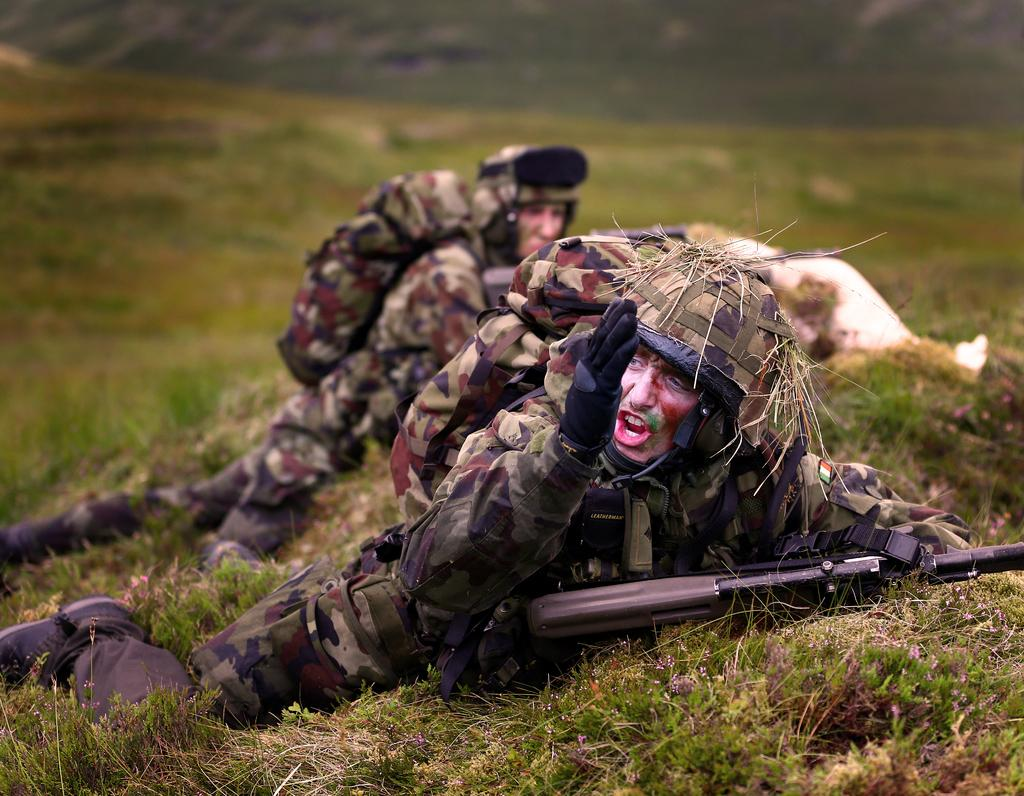What are the people in the image doing? The people in the image are lying on the ground. What objects are the people holding in the image? The people are holding guns in the image. What type of terrain is visible in the image? There is grass visible in the image. How would you describe the background of the image? The background appears blurry in the image. How many legs can be seen on the bed in the image? There is no bed present in the image, so it is not possible to determine the number of legs on a bed. 